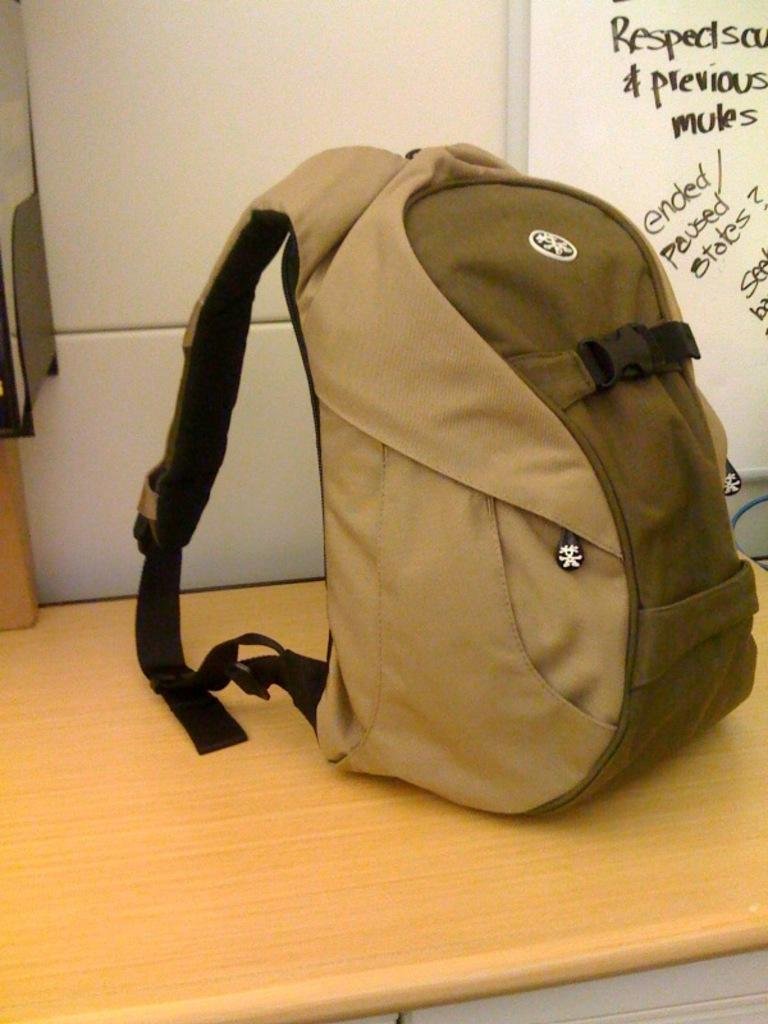<image>
Render a clear and concise summary of the photo. A backpack sits on a surface next to a whiteboard with the words previous, mules, and ended paused states, among others. 